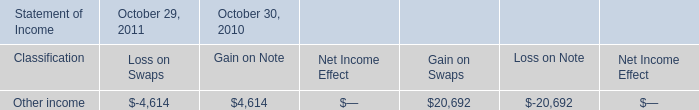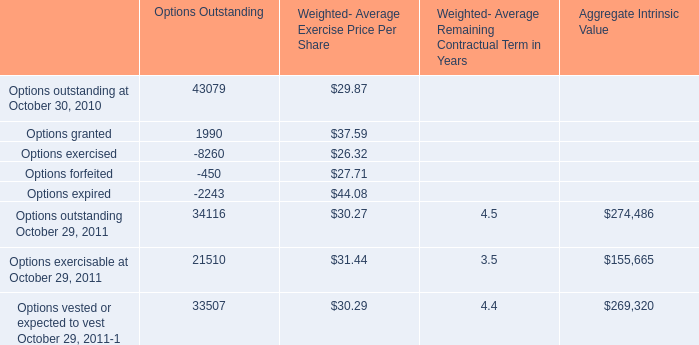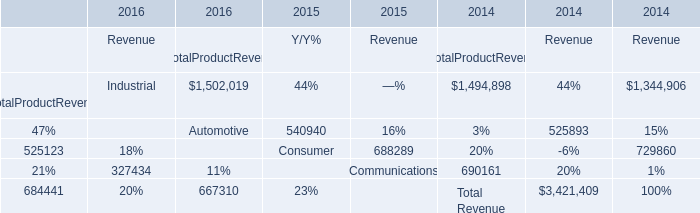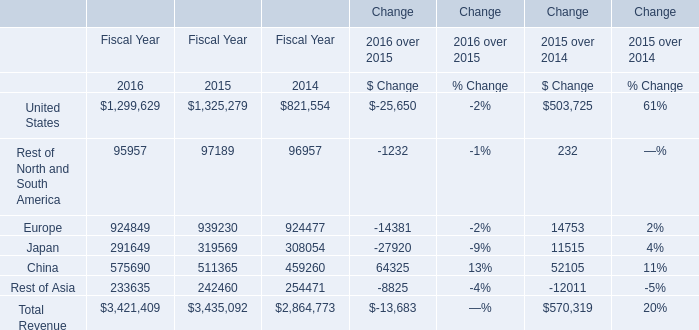What is the ratioof United States to the total in 2016? 
Computations: (1299629 / 3421409)
Answer: 0.37985. 